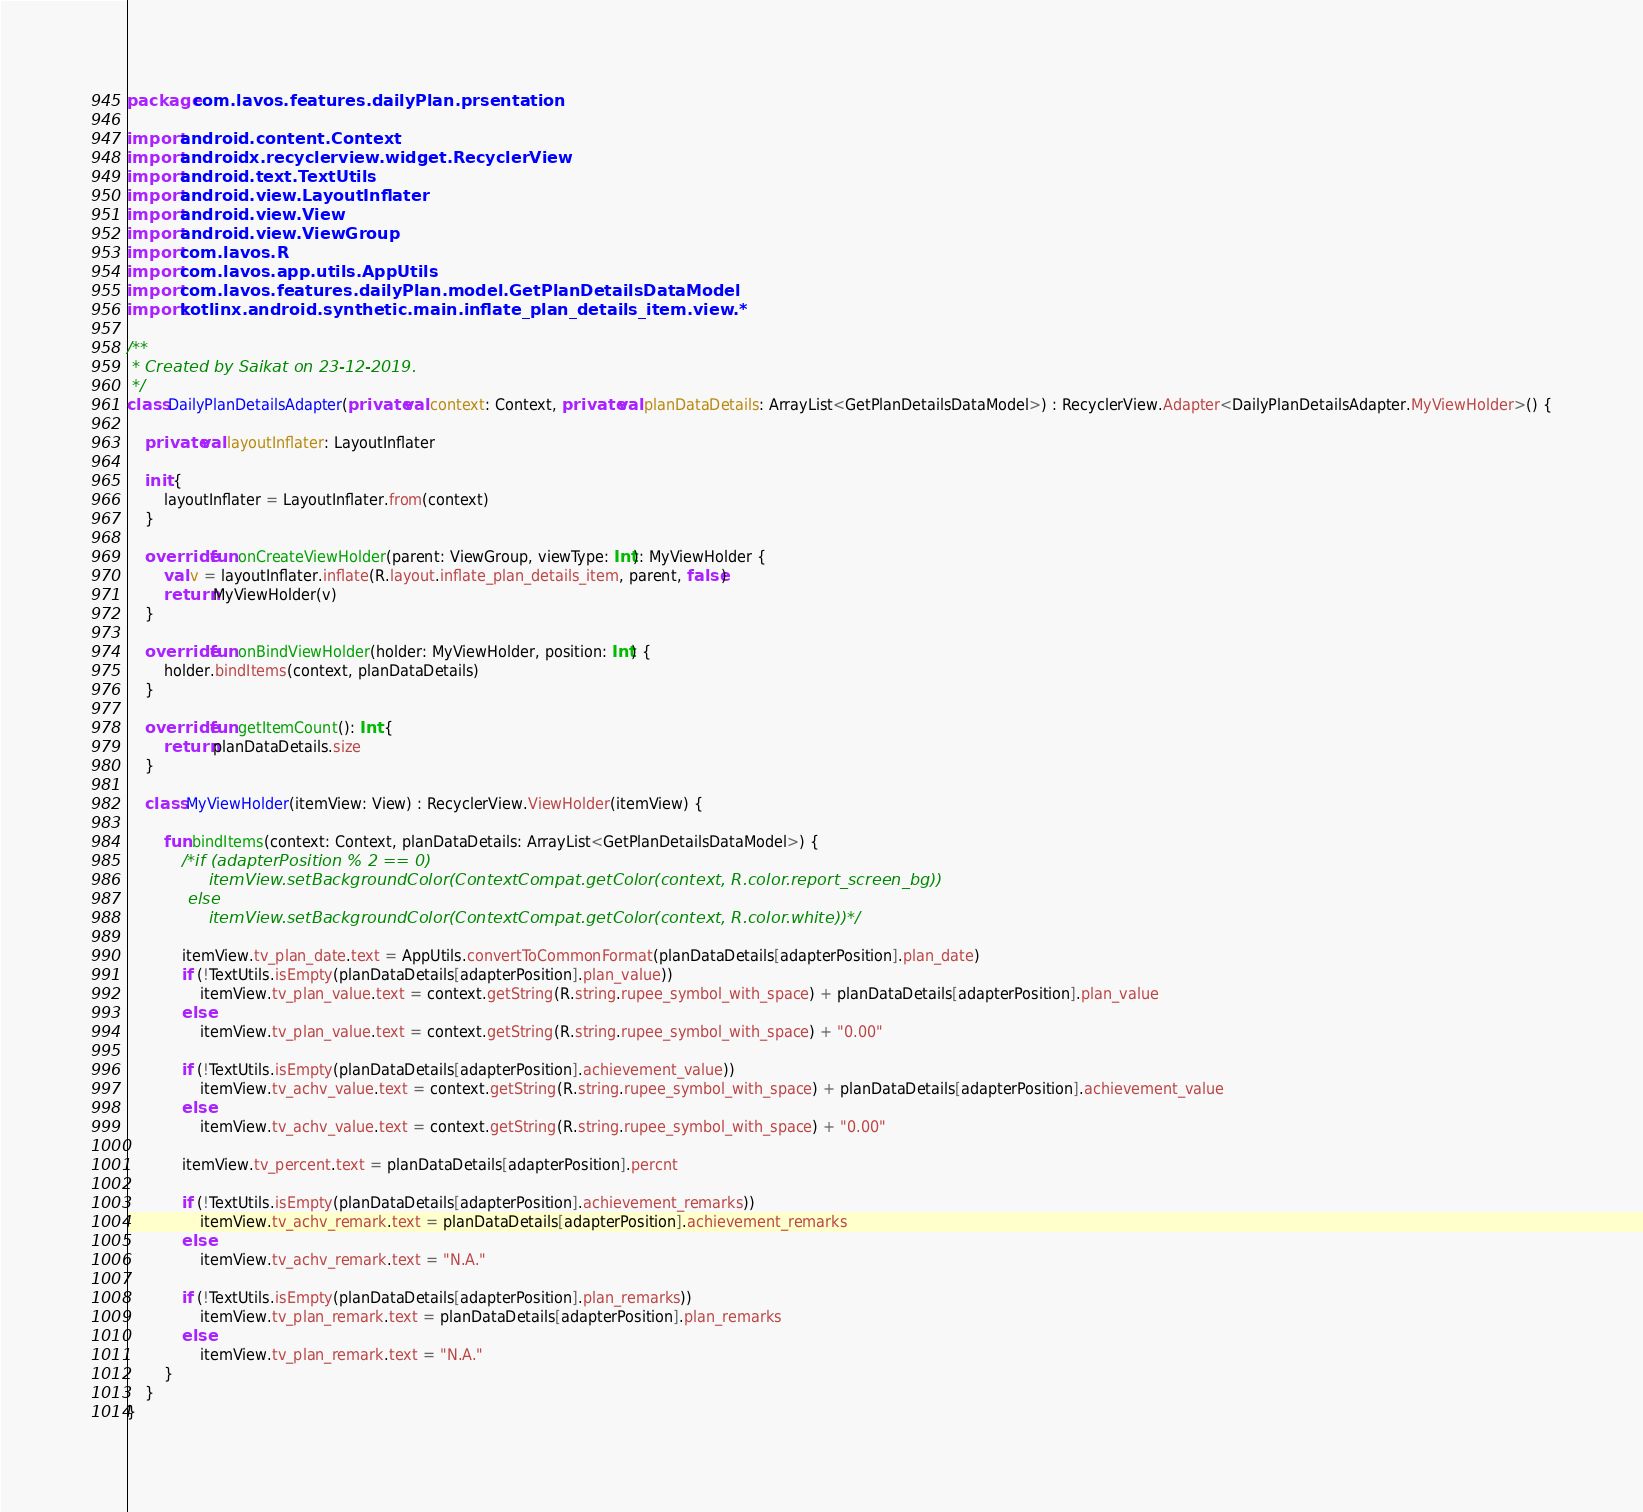Convert code to text. <code><loc_0><loc_0><loc_500><loc_500><_Kotlin_>package com.lavos.features.dailyPlan.prsentation

import android.content.Context
import androidx.recyclerview.widget.RecyclerView
import android.text.TextUtils
import android.view.LayoutInflater
import android.view.View
import android.view.ViewGroup
import com.lavos.R
import com.lavos.app.utils.AppUtils
import com.lavos.features.dailyPlan.model.GetPlanDetailsDataModel
import kotlinx.android.synthetic.main.inflate_plan_details_item.view.*

/**
 * Created by Saikat on 23-12-2019.
 */
class DailyPlanDetailsAdapter(private val context: Context, private val planDataDetails: ArrayList<GetPlanDetailsDataModel>) : RecyclerView.Adapter<DailyPlanDetailsAdapter.MyViewHolder>() {

    private val layoutInflater: LayoutInflater

    init {
        layoutInflater = LayoutInflater.from(context)
    }

    override fun onCreateViewHolder(parent: ViewGroup, viewType: Int): MyViewHolder {
        val v = layoutInflater.inflate(R.layout.inflate_plan_details_item, parent, false)
        return MyViewHolder(v)
    }

    override fun onBindViewHolder(holder: MyViewHolder, position: Int) {
        holder.bindItems(context, planDataDetails)
    }

    override fun getItemCount(): Int {
        return planDataDetails.size
    }

    class MyViewHolder(itemView: View) : RecyclerView.ViewHolder(itemView) {

        fun bindItems(context: Context, planDataDetails: ArrayList<GetPlanDetailsDataModel>) {
            /*if (adapterPosition % 2 == 0)
                itemView.setBackgroundColor(ContextCompat.getColor(context, R.color.report_screen_bg))
            else
                itemView.setBackgroundColor(ContextCompat.getColor(context, R.color.white))*/

            itemView.tv_plan_date.text = AppUtils.convertToCommonFormat(planDataDetails[adapterPosition].plan_date)
            if (!TextUtils.isEmpty(planDataDetails[adapterPosition].plan_value))
                itemView.tv_plan_value.text = context.getString(R.string.rupee_symbol_with_space) + planDataDetails[adapterPosition].plan_value
            else
                itemView.tv_plan_value.text = context.getString(R.string.rupee_symbol_with_space) + "0.00"

            if (!TextUtils.isEmpty(planDataDetails[adapterPosition].achievement_value))
                itemView.tv_achv_value.text = context.getString(R.string.rupee_symbol_with_space) + planDataDetails[adapterPosition].achievement_value
            else
                itemView.tv_achv_value.text = context.getString(R.string.rupee_symbol_with_space) + "0.00"

            itemView.tv_percent.text = planDataDetails[adapterPosition].percnt

            if (!TextUtils.isEmpty(planDataDetails[adapterPosition].achievement_remarks))
                itemView.tv_achv_remark.text = planDataDetails[adapterPosition].achievement_remarks
            else
                itemView.tv_achv_remark.text = "N.A."

            if (!TextUtils.isEmpty(planDataDetails[adapterPosition].plan_remarks))
                itemView.tv_plan_remark.text = planDataDetails[adapterPosition].plan_remarks
            else
                itemView.tv_plan_remark.text = "N.A."
        }
    }
}</code> 